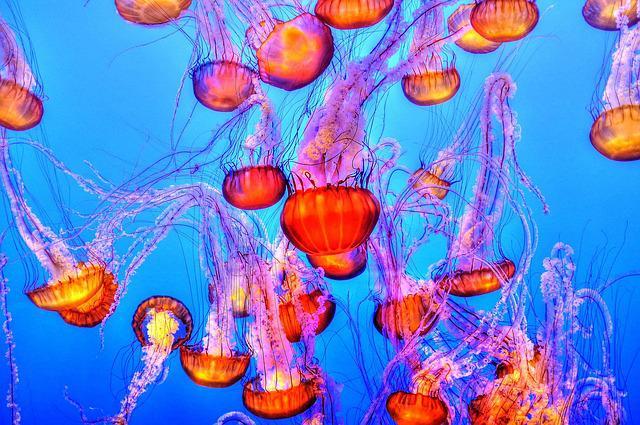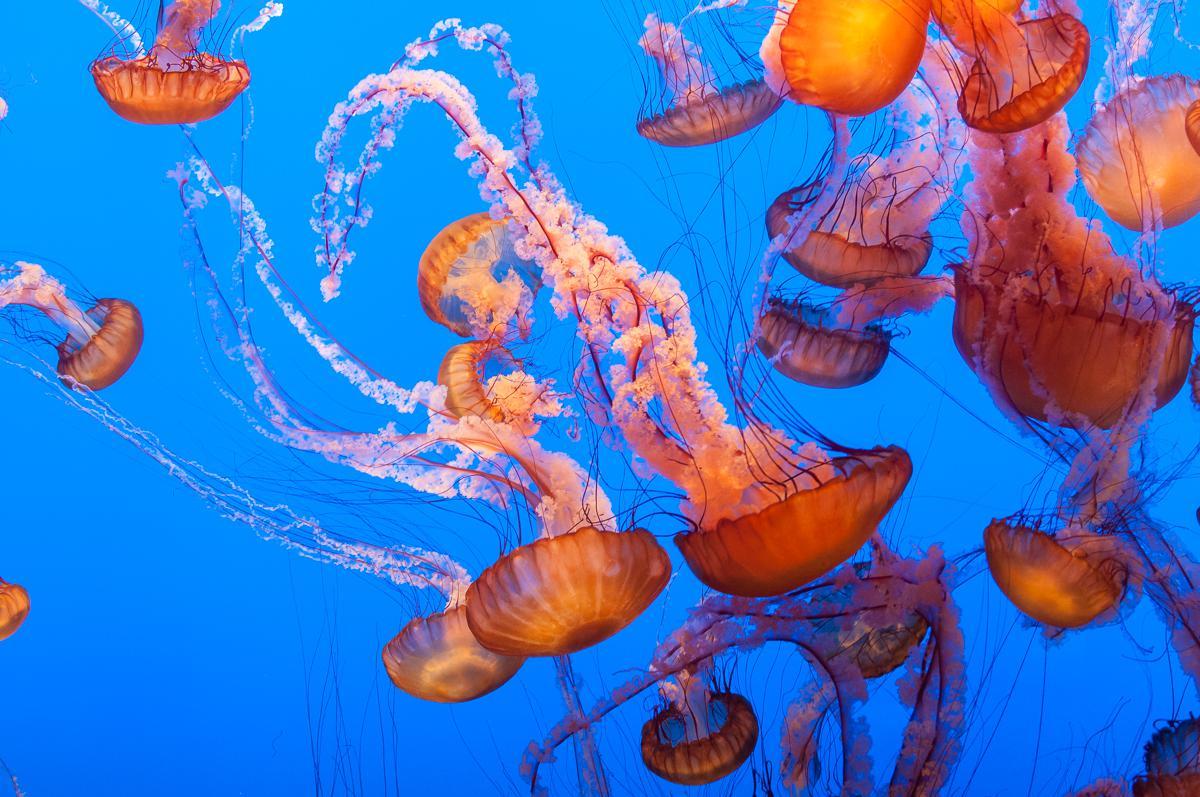The first image is the image on the left, the second image is the image on the right. For the images shown, is this caption "There are at least one hundred light orange jellyfish in the iamge on the left" true? Answer yes or no. No. The first image is the image on the left, the second image is the image on the right. Examine the images to the left and right. Is the description "Jellyfish are the same color in the right and left images." accurate? Answer yes or no. Yes. 